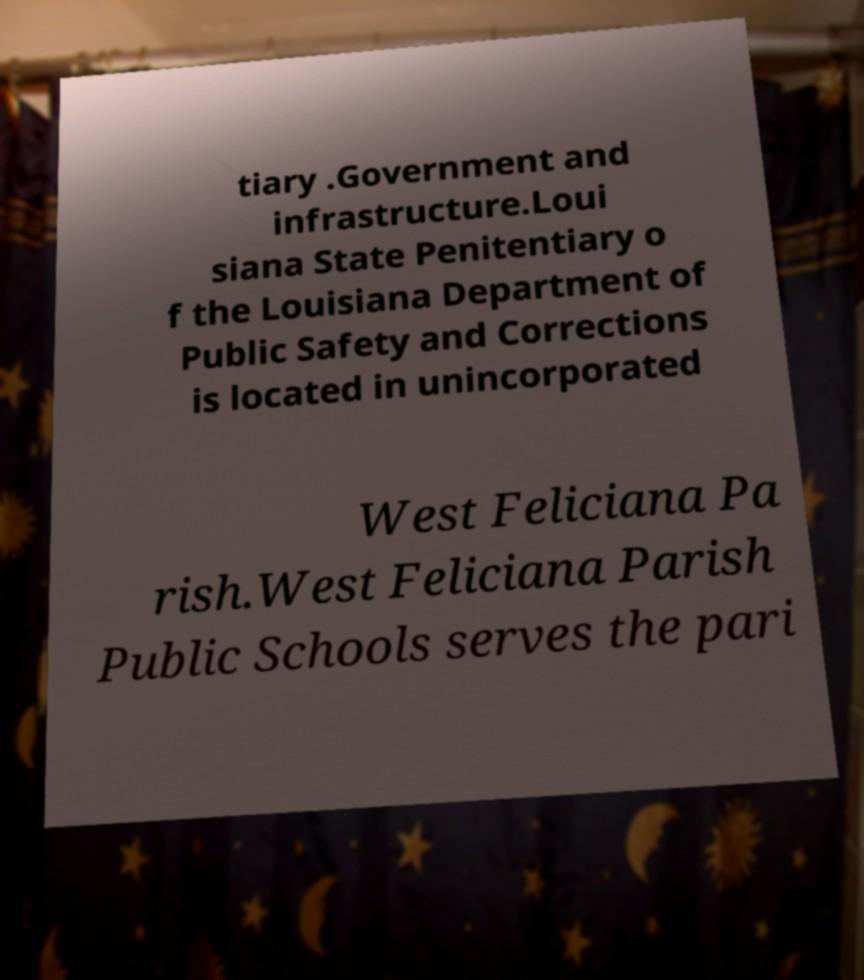Please read and relay the text visible in this image. What does it say? tiary .Government and infrastructure.Loui siana State Penitentiary o f the Louisiana Department of Public Safety and Corrections is located in unincorporated West Feliciana Pa rish.West Feliciana Parish Public Schools serves the pari 